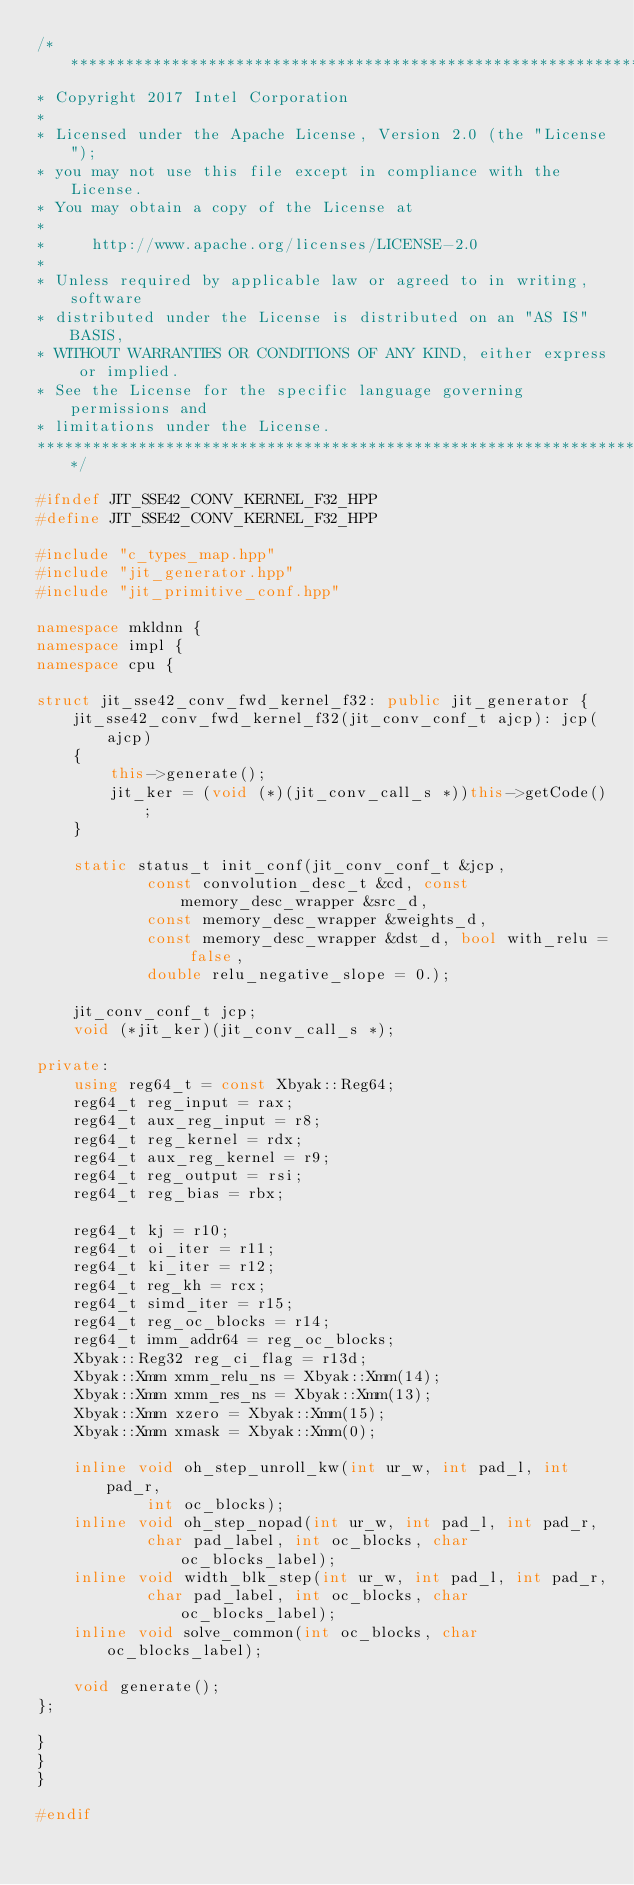Convert code to text. <code><loc_0><loc_0><loc_500><loc_500><_C++_>/*******************************************************************************
* Copyright 2017 Intel Corporation
*
* Licensed under the Apache License, Version 2.0 (the "License");
* you may not use this file except in compliance with the License.
* You may obtain a copy of the License at
*
*     http://www.apache.org/licenses/LICENSE-2.0
*
* Unless required by applicable law or agreed to in writing, software
* distributed under the License is distributed on an "AS IS" BASIS,
* WITHOUT WARRANTIES OR CONDITIONS OF ANY KIND, either express or implied.
* See the License for the specific language governing permissions and
* limitations under the License.
*******************************************************************************/

#ifndef JIT_SSE42_CONV_KERNEL_F32_HPP
#define JIT_SSE42_CONV_KERNEL_F32_HPP

#include "c_types_map.hpp"
#include "jit_generator.hpp"
#include "jit_primitive_conf.hpp"

namespace mkldnn {
namespace impl {
namespace cpu {

struct jit_sse42_conv_fwd_kernel_f32: public jit_generator {
    jit_sse42_conv_fwd_kernel_f32(jit_conv_conf_t ajcp): jcp(ajcp)
    {
        this->generate();
        jit_ker = (void (*)(jit_conv_call_s *))this->getCode();
    }

    static status_t init_conf(jit_conv_conf_t &jcp,
            const convolution_desc_t &cd, const memory_desc_wrapper &src_d,
            const memory_desc_wrapper &weights_d,
            const memory_desc_wrapper &dst_d, bool with_relu = false,
            double relu_negative_slope = 0.);

    jit_conv_conf_t jcp;
    void (*jit_ker)(jit_conv_call_s *);

private:
    using reg64_t = const Xbyak::Reg64;
    reg64_t reg_input = rax;
    reg64_t aux_reg_input = r8;
    reg64_t reg_kernel = rdx;
    reg64_t aux_reg_kernel = r9;
    reg64_t reg_output = rsi;
    reg64_t reg_bias = rbx;

    reg64_t kj = r10;
    reg64_t oi_iter = r11;
    reg64_t ki_iter = r12;
    reg64_t reg_kh = rcx;
    reg64_t simd_iter = r15;
    reg64_t reg_oc_blocks = r14;
    reg64_t imm_addr64 = reg_oc_blocks;
    Xbyak::Reg32 reg_ci_flag = r13d;
    Xbyak::Xmm xmm_relu_ns = Xbyak::Xmm(14);
    Xbyak::Xmm xmm_res_ns = Xbyak::Xmm(13);
    Xbyak::Xmm xzero = Xbyak::Xmm(15);
    Xbyak::Xmm xmask = Xbyak::Xmm(0);

    inline void oh_step_unroll_kw(int ur_w, int pad_l, int pad_r,
            int oc_blocks);
    inline void oh_step_nopad(int ur_w, int pad_l, int pad_r,
            char pad_label, int oc_blocks, char oc_blocks_label);
    inline void width_blk_step(int ur_w, int pad_l, int pad_r,
            char pad_label, int oc_blocks, char oc_blocks_label);
    inline void solve_common(int oc_blocks, char oc_blocks_label);

    void generate();
};

}
}
}

#endif
</code> 